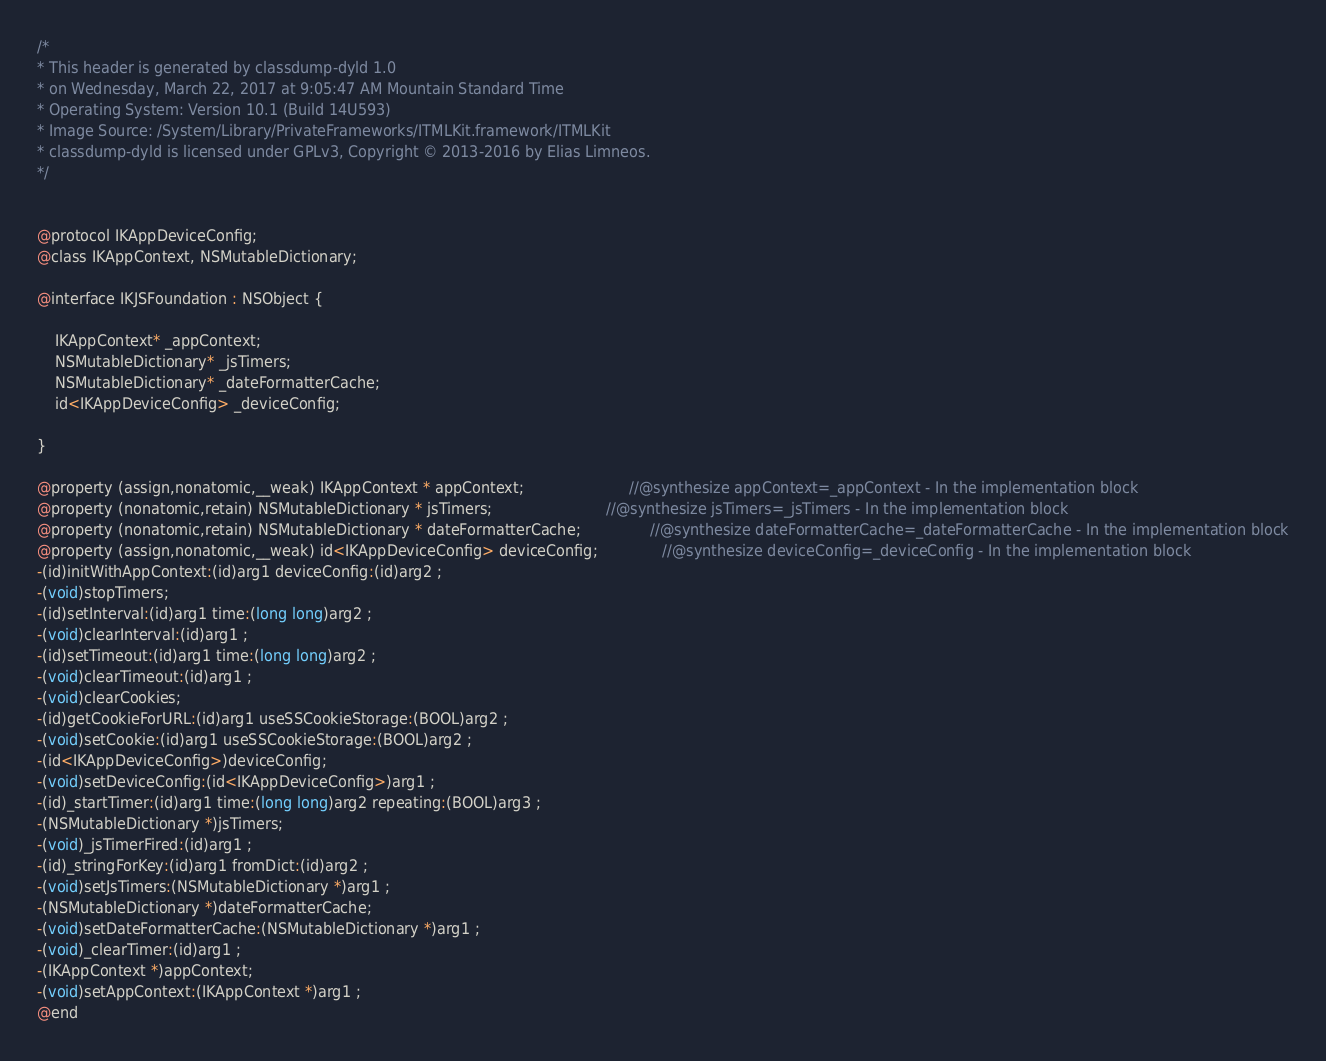<code> <loc_0><loc_0><loc_500><loc_500><_C_>/*
* This header is generated by classdump-dyld 1.0
* on Wednesday, March 22, 2017 at 9:05:47 AM Mountain Standard Time
* Operating System: Version 10.1 (Build 14U593)
* Image Source: /System/Library/PrivateFrameworks/ITMLKit.framework/ITMLKit
* classdump-dyld is licensed under GPLv3, Copyright © 2013-2016 by Elias Limneos.
*/


@protocol IKAppDeviceConfig;
@class IKAppContext, NSMutableDictionary;

@interface IKJSFoundation : NSObject {

	IKAppContext* _appContext;
	NSMutableDictionary* _jsTimers;
	NSMutableDictionary* _dateFormatterCache;
	id<IKAppDeviceConfig> _deviceConfig;

}

@property (assign,nonatomic,__weak) IKAppContext * appContext;                       //@synthesize appContext=_appContext - In the implementation block
@property (nonatomic,retain) NSMutableDictionary * jsTimers;                         //@synthesize jsTimers=_jsTimers - In the implementation block
@property (nonatomic,retain) NSMutableDictionary * dateFormatterCache;               //@synthesize dateFormatterCache=_dateFormatterCache - In the implementation block
@property (assign,nonatomic,__weak) id<IKAppDeviceConfig> deviceConfig;              //@synthesize deviceConfig=_deviceConfig - In the implementation block
-(id)initWithAppContext:(id)arg1 deviceConfig:(id)arg2 ;
-(void)stopTimers;
-(id)setInterval:(id)arg1 time:(long long)arg2 ;
-(void)clearInterval:(id)arg1 ;
-(id)setTimeout:(id)arg1 time:(long long)arg2 ;
-(void)clearTimeout:(id)arg1 ;
-(void)clearCookies;
-(id)getCookieForURL:(id)arg1 useSSCookieStorage:(BOOL)arg2 ;
-(void)setCookie:(id)arg1 useSSCookieStorage:(BOOL)arg2 ;
-(id<IKAppDeviceConfig>)deviceConfig;
-(void)setDeviceConfig:(id<IKAppDeviceConfig>)arg1 ;
-(id)_startTimer:(id)arg1 time:(long long)arg2 repeating:(BOOL)arg3 ;
-(NSMutableDictionary *)jsTimers;
-(void)_jsTimerFired:(id)arg1 ;
-(id)_stringForKey:(id)arg1 fromDict:(id)arg2 ;
-(void)setJsTimers:(NSMutableDictionary *)arg1 ;
-(NSMutableDictionary *)dateFormatterCache;
-(void)setDateFormatterCache:(NSMutableDictionary *)arg1 ;
-(void)_clearTimer:(id)arg1 ;
-(IKAppContext *)appContext;
-(void)setAppContext:(IKAppContext *)arg1 ;
@end

</code> 